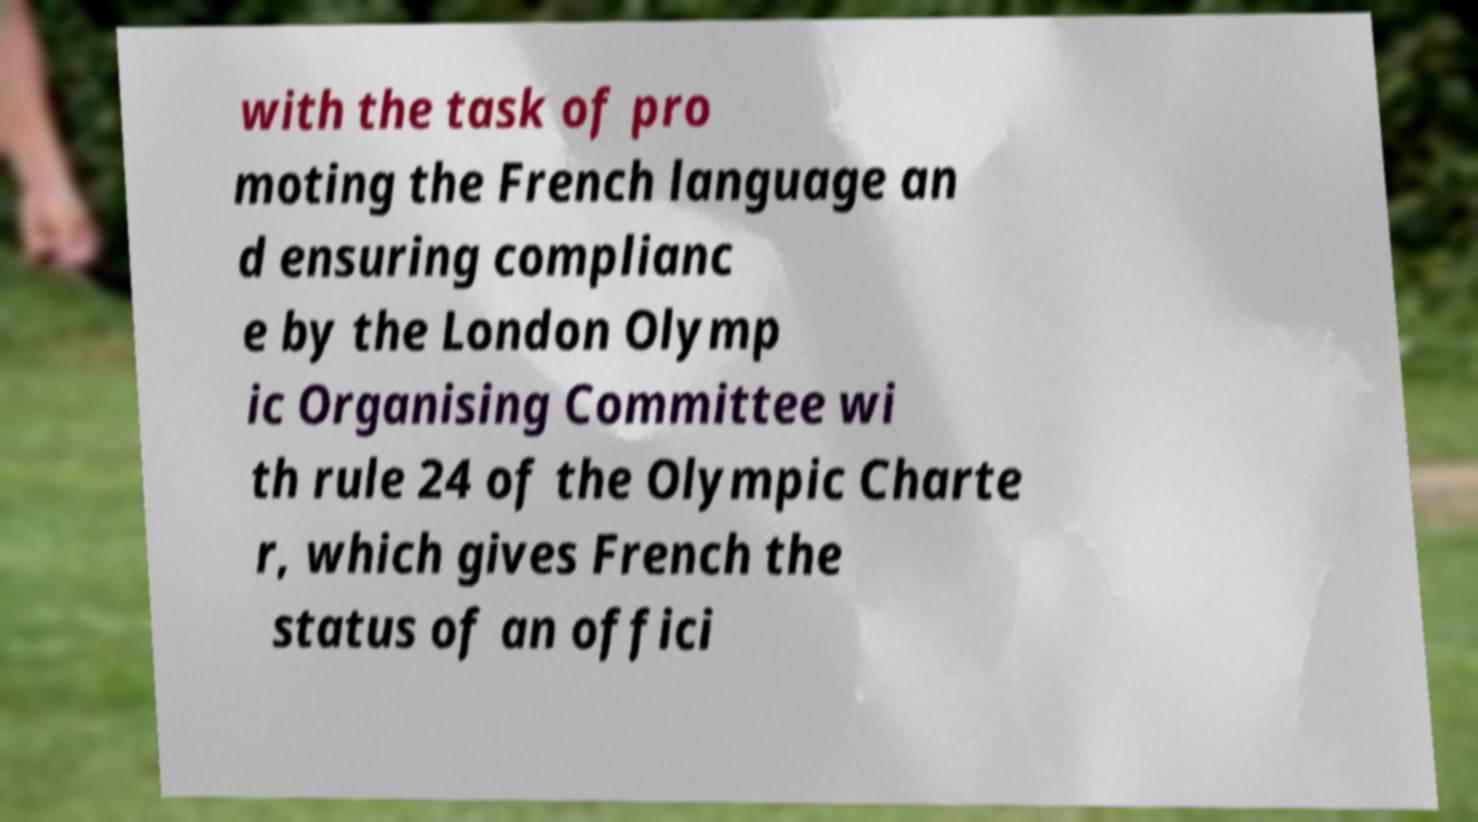Can you accurately transcribe the text from the provided image for me? with the task of pro moting the French language an d ensuring complianc e by the London Olymp ic Organising Committee wi th rule 24 of the Olympic Charte r, which gives French the status of an offici 